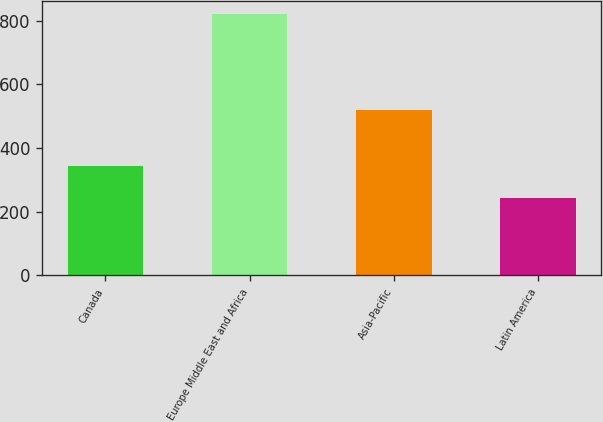Convert chart. <chart><loc_0><loc_0><loc_500><loc_500><bar_chart><fcel>Canada<fcel>Europe Middle East and Africa<fcel>Asia-Pacific<fcel>Latin America<nl><fcel>342.9<fcel>821.3<fcel>518.7<fcel>242.6<nl></chart> 